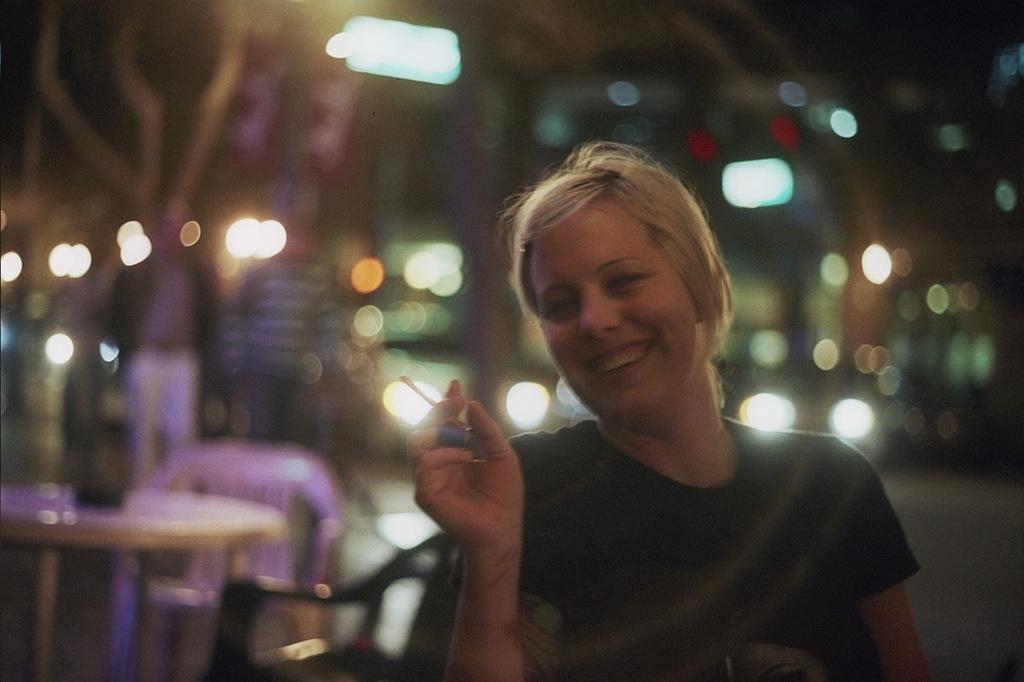What is the main subject of the image? There is a lady standing in the image. What is the lady holding in her hand? The lady is holding a cigarette in her hand. Can you describe the background of the image? The background of the image is blurred. How many cattle can be seen grazing in the background of the image? There are no cattle present in the image; the background is blurred. What type of plants are growing near the lady in the image? There is no information about plants in the image; it only shows a lady holding a cigarette with a blurred background. 